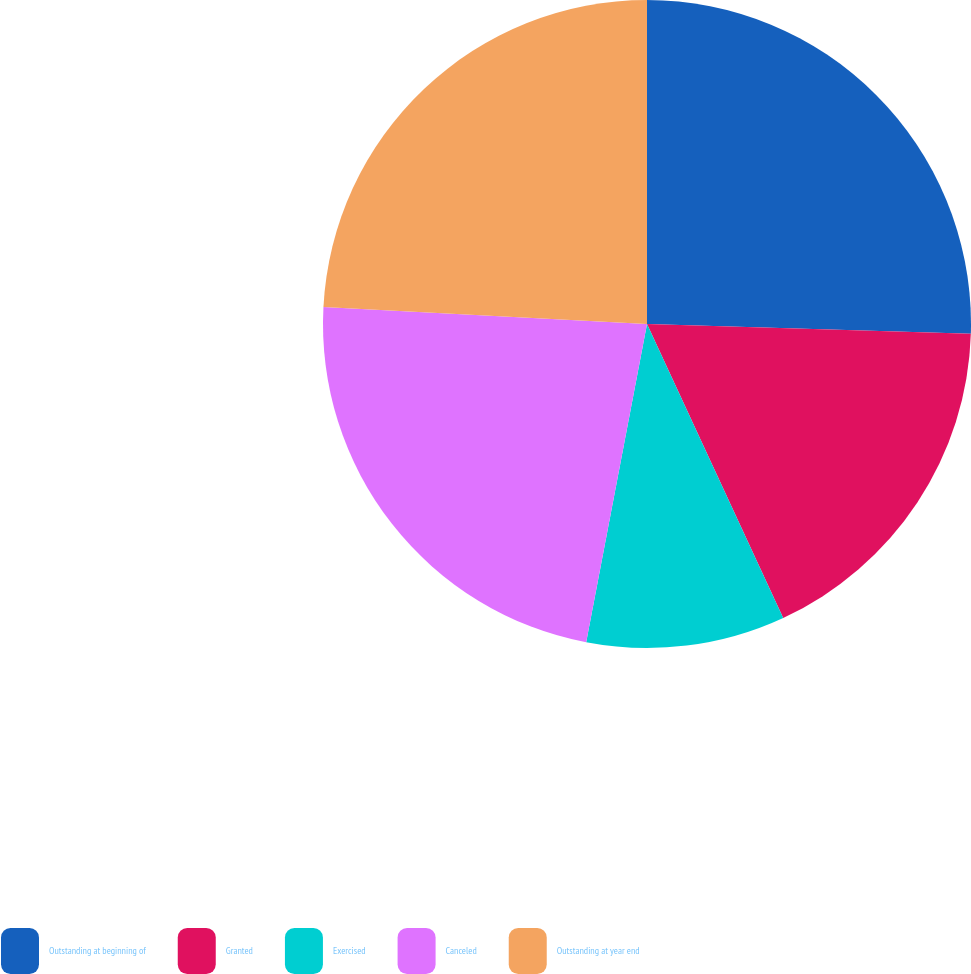Convert chart. <chart><loc_0><loc_0><loc_500><loc_500><pie_chart><fcel>Outstanding at beginning of<fcel>Granted<fcel>Exercised<fcel>Canceled<fcel>Outstanding at year end<nl><fcel>25.48%<fcel>17.61%<fcel>9.91%<fcel>22.83%<fcel>24.16%<nl></chart> 